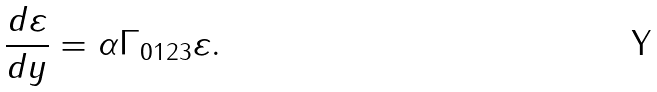<formula> <loc_0><loc_0><loc_500><loc_500>\frac { d \varepsilon } { d y } = \alpha \Gamma _ { 0 1 2 3 } \varepsilon .</formula> 